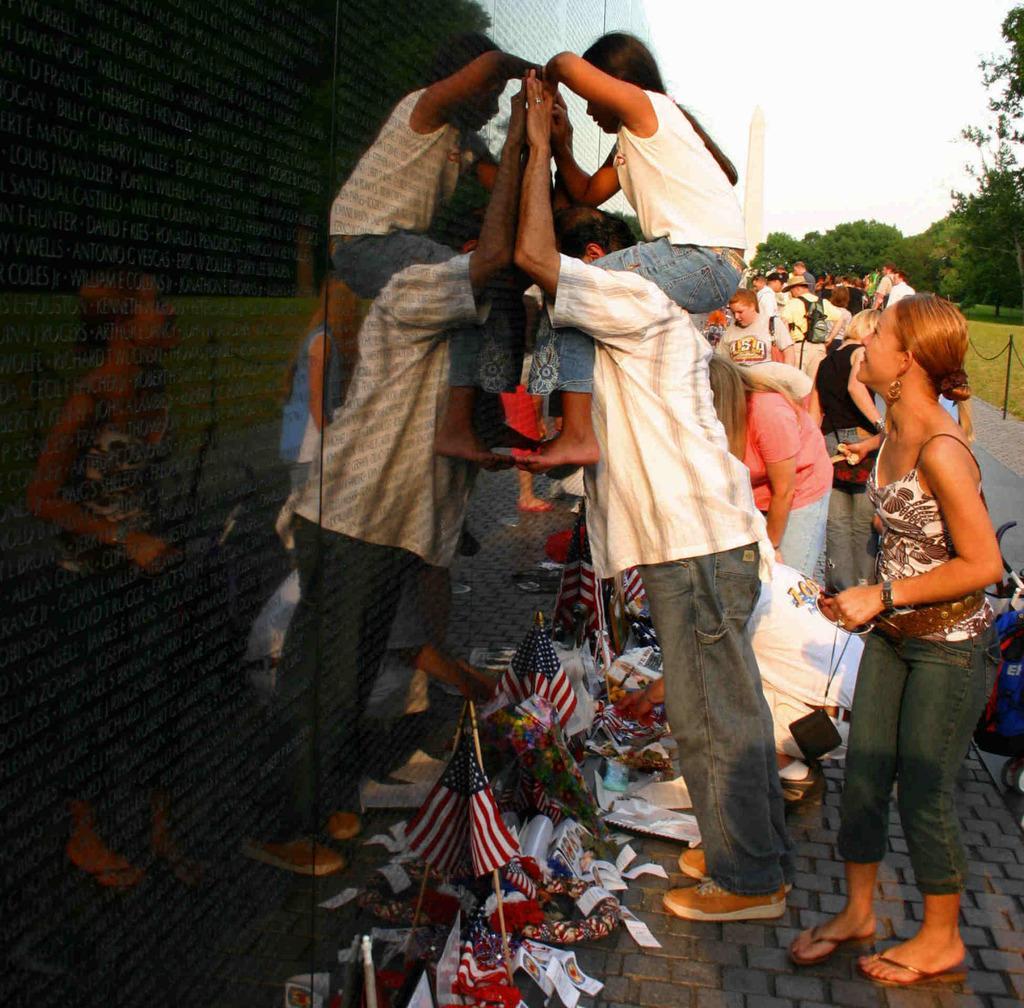Please provide a concise description of this image. In this picture we can see a few flags and some colorful objects on the path. We can see a girl sitting on the shoulder of a man and looking in the building. We can see a woman and a blue color object on the right side. There is a pole and a chain. We can see some grass on the ground. There are a few trees visible in the background. 